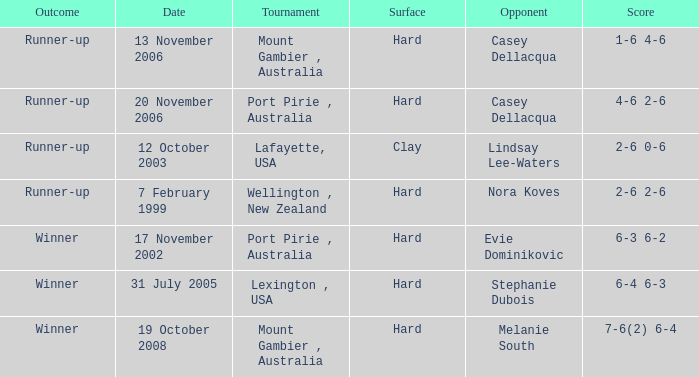Which points have a competitor of melanie south achieved? 7-6(2) 6-4. 